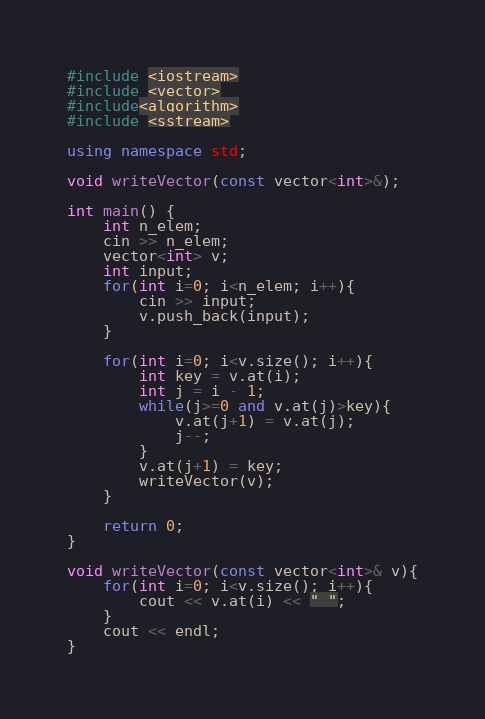<code> <loc_0><loc_0><loc_500><loc_500><_C++_>#include <iostream>
#include <vector>
#include<algorithm>
#include <sstream>

using namespace std;

void writeVector(const vector<int>&);

int main() {
	int n_elem;
	cin >> n_elem;
    vector<int> v;
    int input;
    for(int i=0; i<n_elem; i++){
    	cin >> input;
    	v.push_back(input);
    }

	for(int i=0; i<v.size(); i++){
		int key = v.at(i);
		int j = i - 1;
		while(j>=0 and v.at(j)>key){
			v.at(j+1) = v.at(j);
			j--;
		}
		v.at(j+1) = key;
		writeVector(v);
	}

	return 0;
}

void writeVector(const vector<int>& v){
	for(int i=0; i<v.size(); i++){
		cout << v.at(i) << " ";
	}
	cout << endl;
}
</code> 